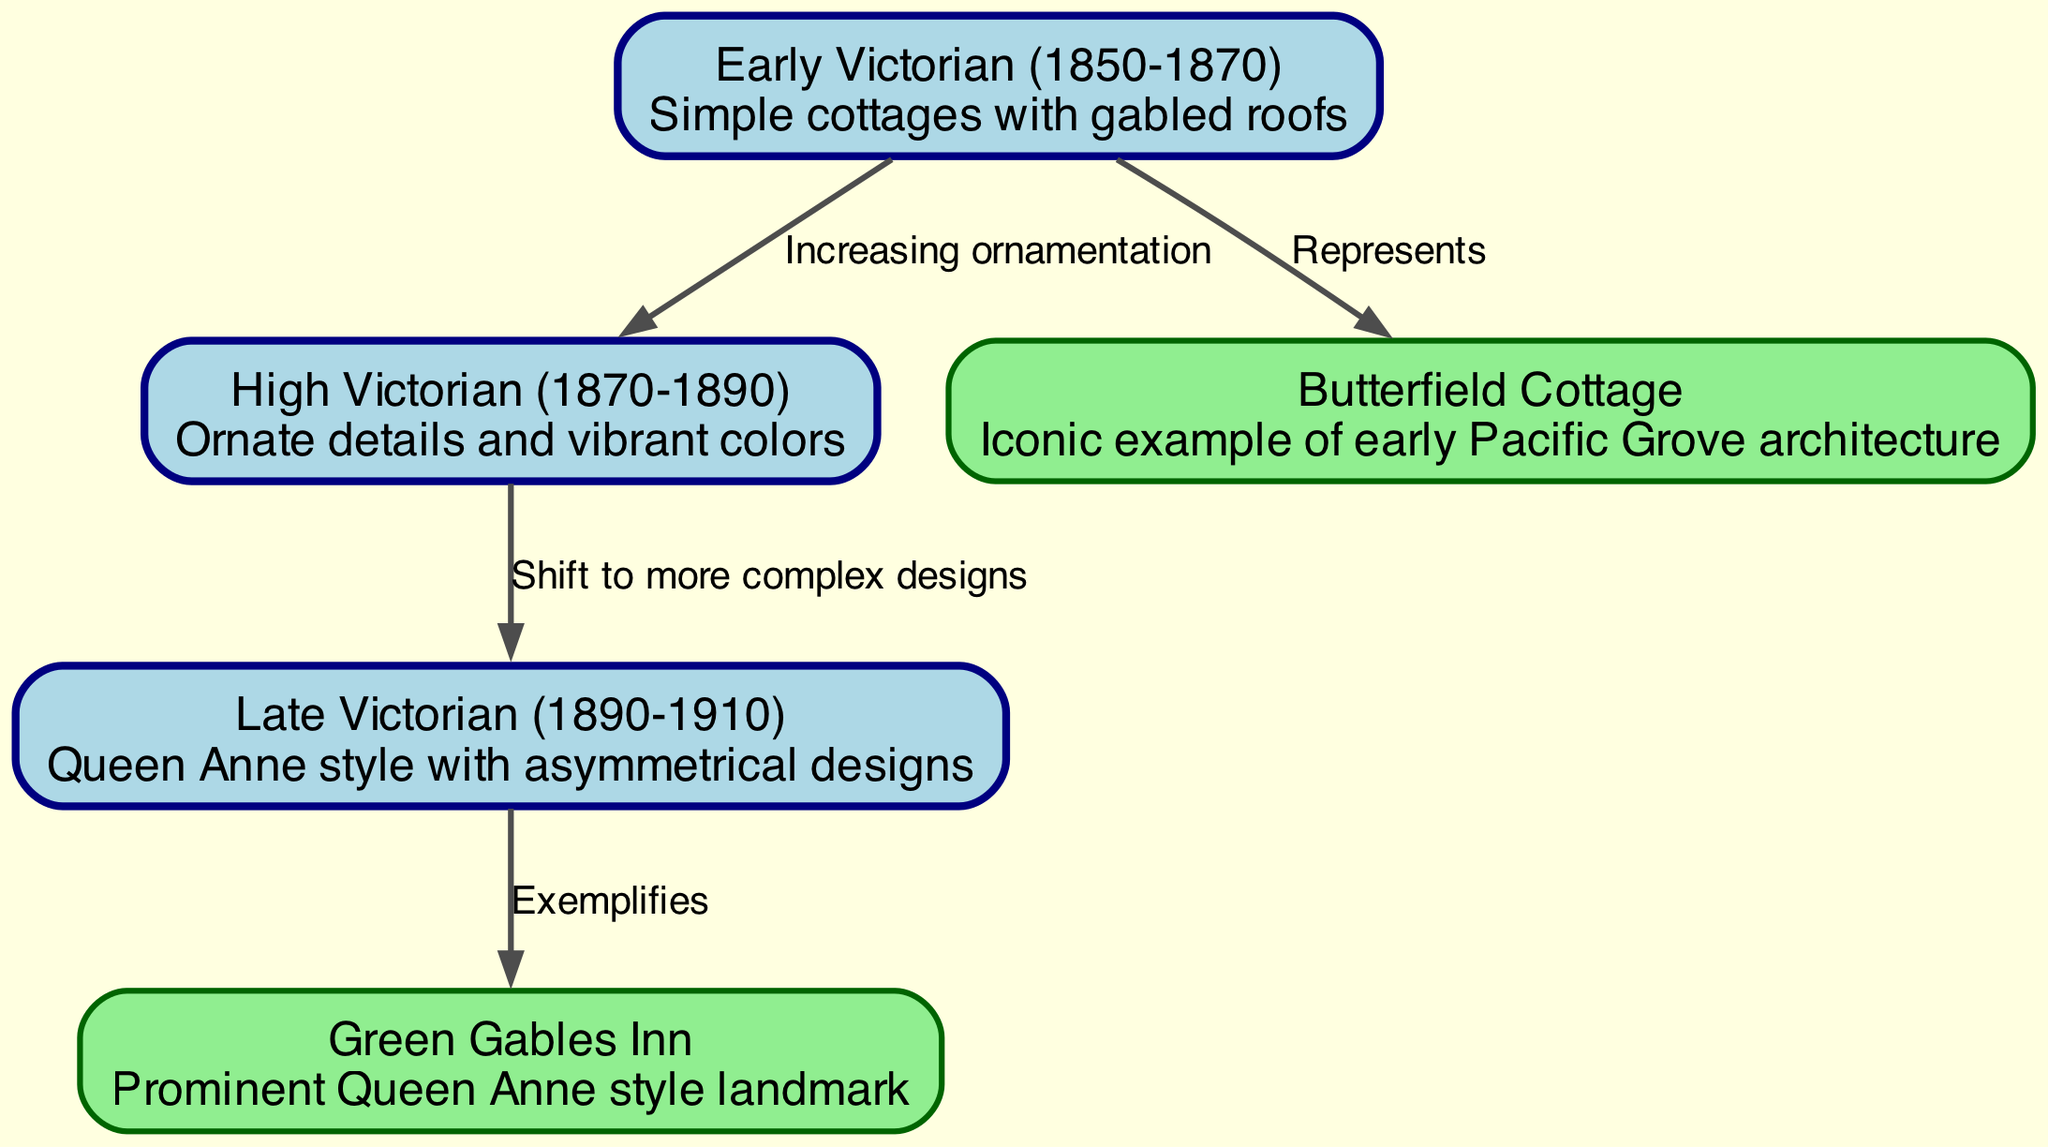What is the style of the Butterfield Cottage? The Butterfield Cottage is labeled as an "Iconic example of early Pacific Grove architecture," indicating that it represents the Early Victorian style.
Answer: Early Victorian How many distinct architectural styles are represented in the diagram? The diagram shows three architectural styles: Early Victorian, High Victorian, and Late Victorian, making a total of three distinct styles.
Answer: 3 What relationship exists between High Victorian and Late Victorian styles? The diagram indicates a connection from High Victorian to Late Victorian labeled "Shift to more complex designs," suggesting an evolution in architectural design complexity from High Victorian to Late Victorian.
Answer: Shift to more complex designs Which building exemplifies the Late Victorian style? The Green Gables Inn is identified as a "Prominent Queen Anne style landmark," which corresponds to the Late Victorian architectural style, specifically the Queen Anne style of that period.
Answer: Green Gables Inn What structural characteristics define the Early Victorian style? The Early Victorian style is described in the diagram as "Simple cottages with gabled roofs," which showcases its basic structural characteristics, emphasizing simplicity.
Answer: Simple cottages with gabled roofs Which architectural style shows an increase in ornamentation? The diagram explicitly states that there is "Increasing ornamentation" from Early Victorian to High Victorian, which signifies that High Victorian is the style showing increased ornamentation.
Answer: High Victorian 